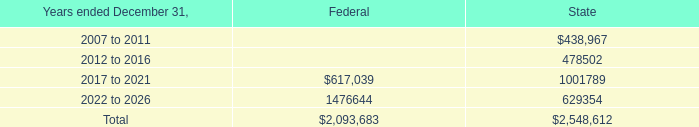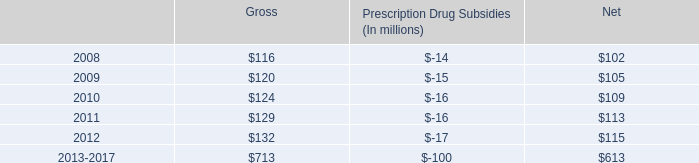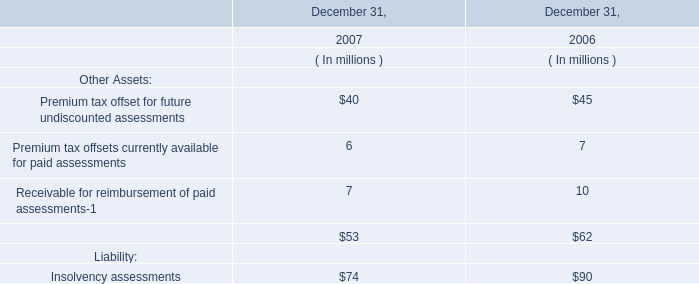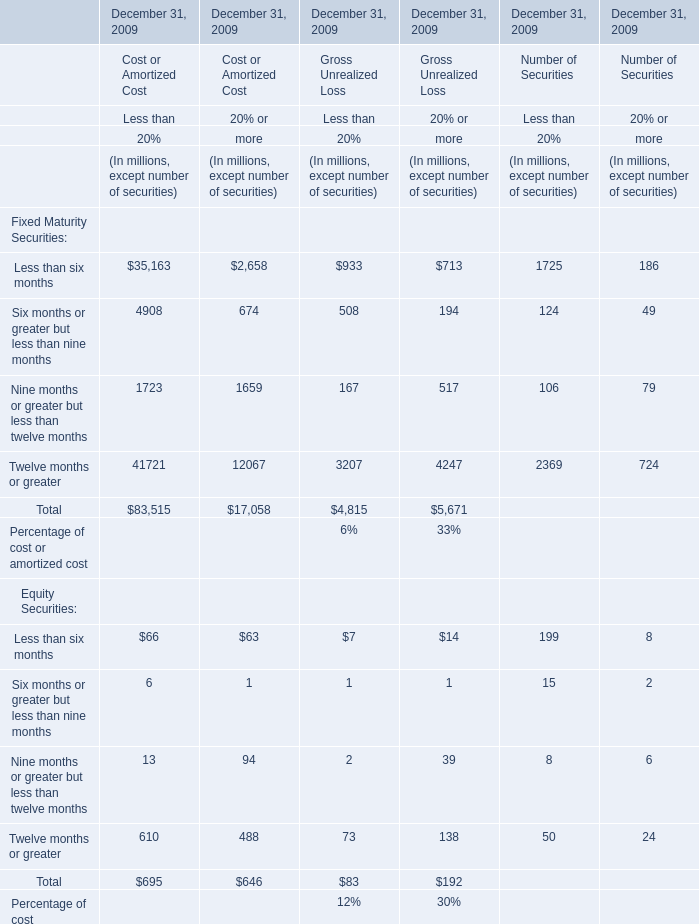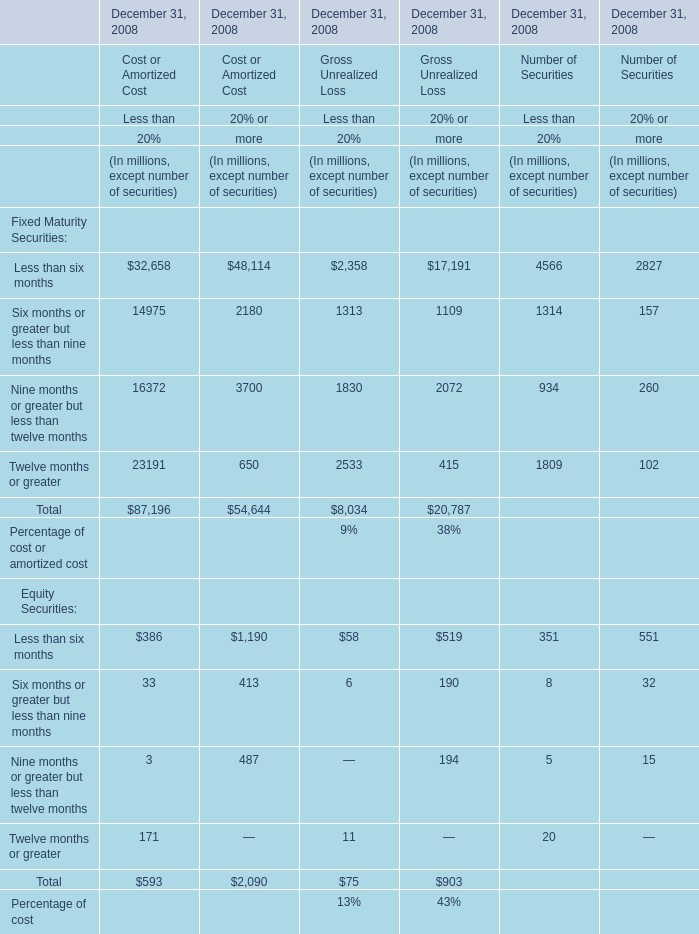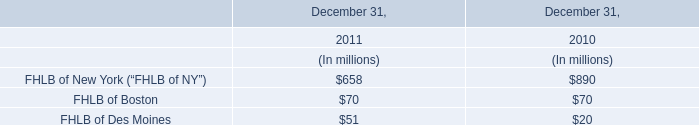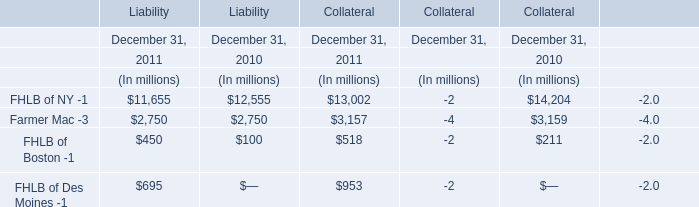What was the average value of the Less than six months of Equity Securities in the year where Less than six months of Fixed Maturity Securities is positive? (in million) 
Computations: ((((((386 + 1190) + 58) + 519) + 351) + 551) / 1)
Answer: 3055.0. 